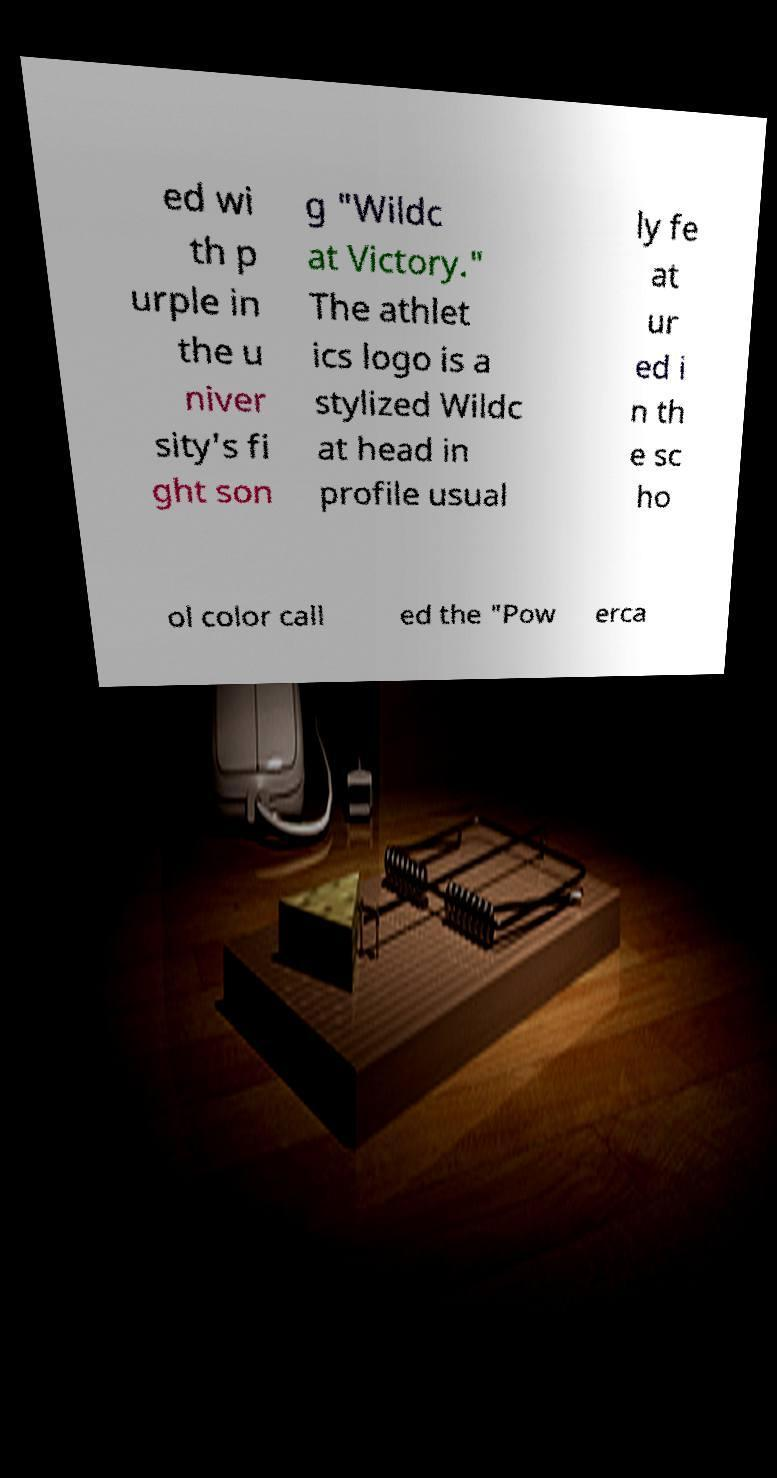What messages or text are displayed in this image? I need them in a readable, typed format. ed wi th p urple in the u niver sity's fi ght son g "Wildc at Victory." The athlet ics logo is a stylized Wildc at head in profile usual ly fe at ur ed i n th e sc ho ol color call ed the "Pow erca 